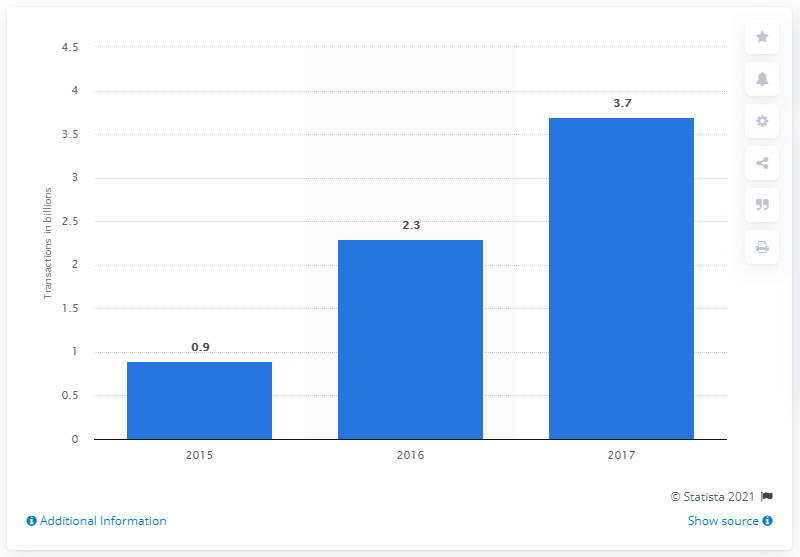Specify some key components in this picture. Adyen processed 3.7 payment transactions in 2017. 